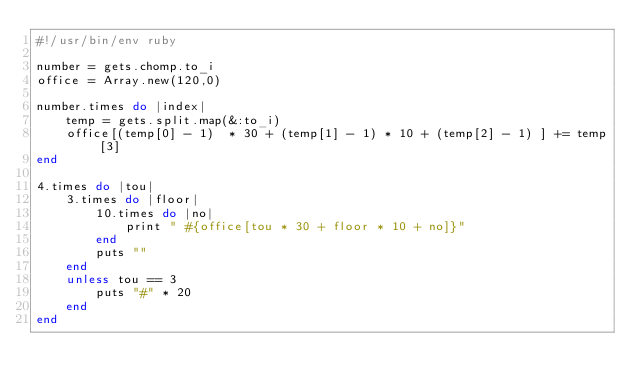<code> <loc_0><loc_0><loc_500><loc_500><_Ruby_>#!/usr/bin/env ruby

number = gets.chomp.to_i
office = Array.new(120,0)

number.times do |index|
    temp = gets.split.map(&:to_i)
    office[(temp[0] - 1)  * 30 + (temp[1] - 1) * 10 + (temp[2] - 1) ] += temp[3]
end

4.times do |tou|
    3.times do |floor|
        10.times do |no|
            print " #{office[tou * 30 + floor * 10 + no]}"
        end
        puts ""
    end
    unless tou == 3
        puts "#" * 20
    end
end
</code> 